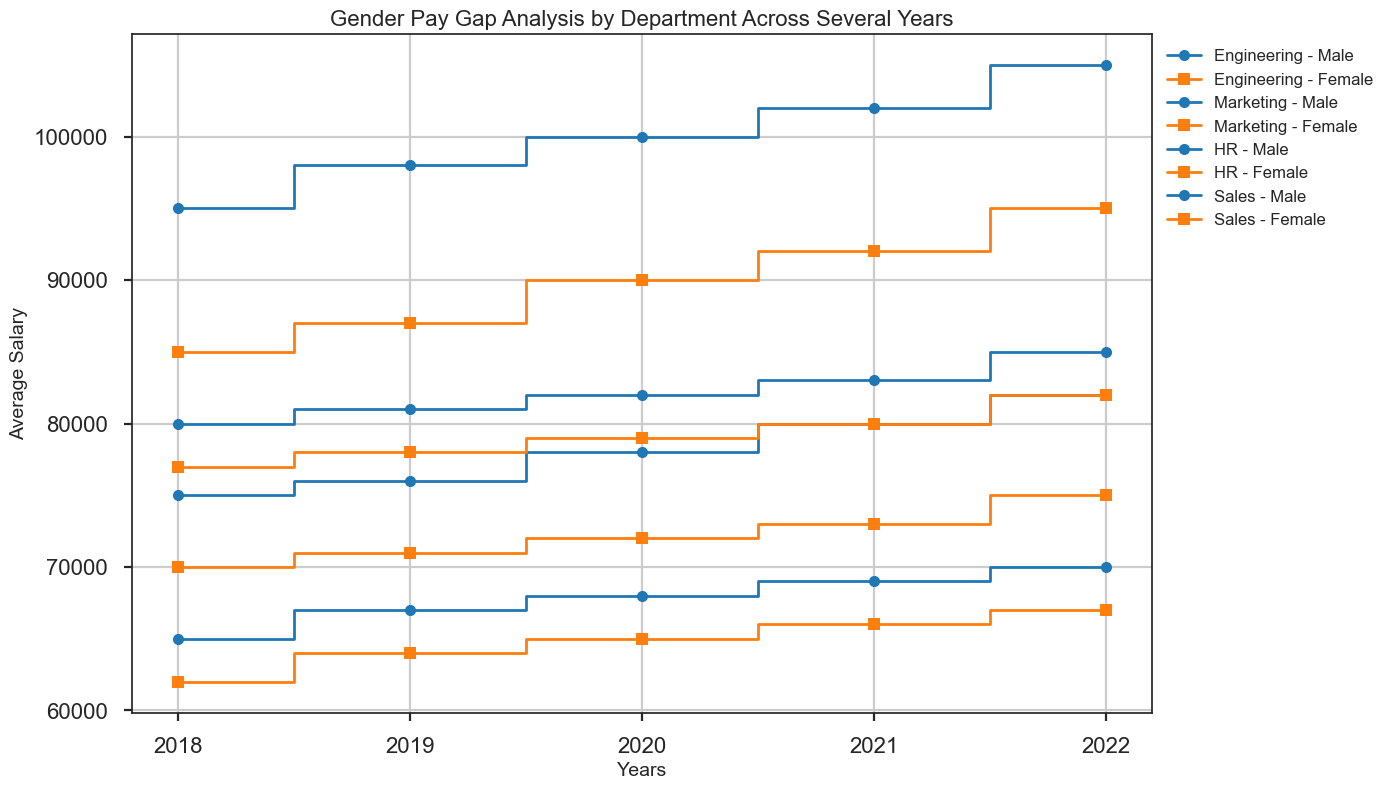How did the average salary of males in the Engineering department change from 2018 to 2022? Look at the data points for males in the Engineering department at the years 2018 and 2022. In 2018, the average salary was 95,000, and in 2022, it was 105,000. The change is 105,000 - 95,000 = 10,000
Answer: Increased by 10,000 Which department had the smallest gender pay gap in 2022? Compare the average salaries of males and females across all departments in 2022. Calculate the differences: Engineering (105,000-95,000 = 10,000), Marketing (82,000-75,000 = 7,000), HR (70,000-67,000 = 3,000), and Sales (85,000-82,000 = 3,000). The smallest difference is in Sales and HR, both with a gap of 3,000
Answer: Sales and HR In which year did the Sales department see the smallest difference in average salary between males and females? Look at the steps for the Sales department across all years. Calculate the differences for each year: 2018 (80,000-77,000 = 3,000), 2019 (81,000-78,000 = 3,000), 2020 (82,000-79,000 = 3,000), 2021 (83,000-80,000 = 3,000), 2022 (85,000-82,000 = 3,000). The smallest difference is consistent across all years, making it 3,000 each year.
Answer: 2018-2022 (all years) Was there any year where the average salary of females in the Marketing department was higher than in the HR department? Compare the average salaries of females in the Marketing and HR departments for each year: 2018 (70,000 vs 62,000), 2019 (71,000 vs 64,000), 2020 (72,000 vs 65,000), 2021 (73,000 vs 66,000), 2022 (75,000 vs 67,000). In all years, Marketing had higher average salaries than HR.
Answer: All years What is the overall trend in the average salaries for males and females in the Engineering department from 2018 to 2022? Analyze the step lines for the Engineering department. For males: 2018 (95,000), 2019 (98,000), 2020 (100,000), 2021 (102,000), 2022 (105,000). For females: 2018 (85,000), 2019 (87,000), 2020 (90,000), 2021 (92,000), 2022 (95,000). Both lines show a consistent increasing trend.
Answer: Increasing trend 